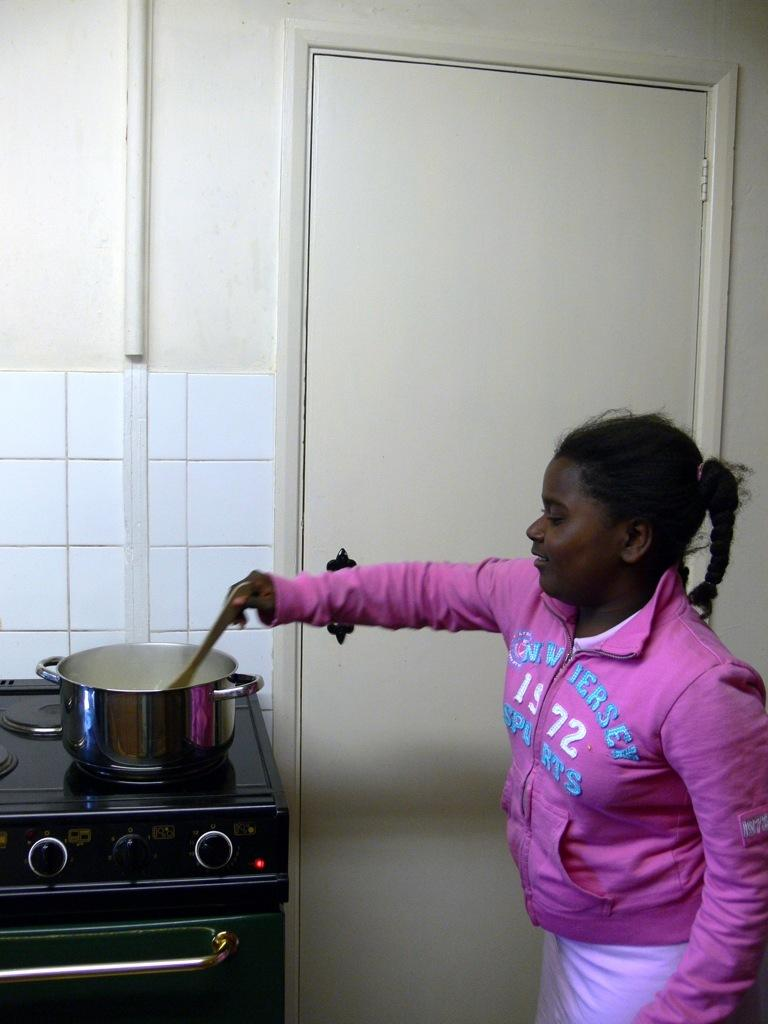<image>
Provide a brief description of the given image. A girl cooking in a 1972 N. Wiersey Sports pink top. 